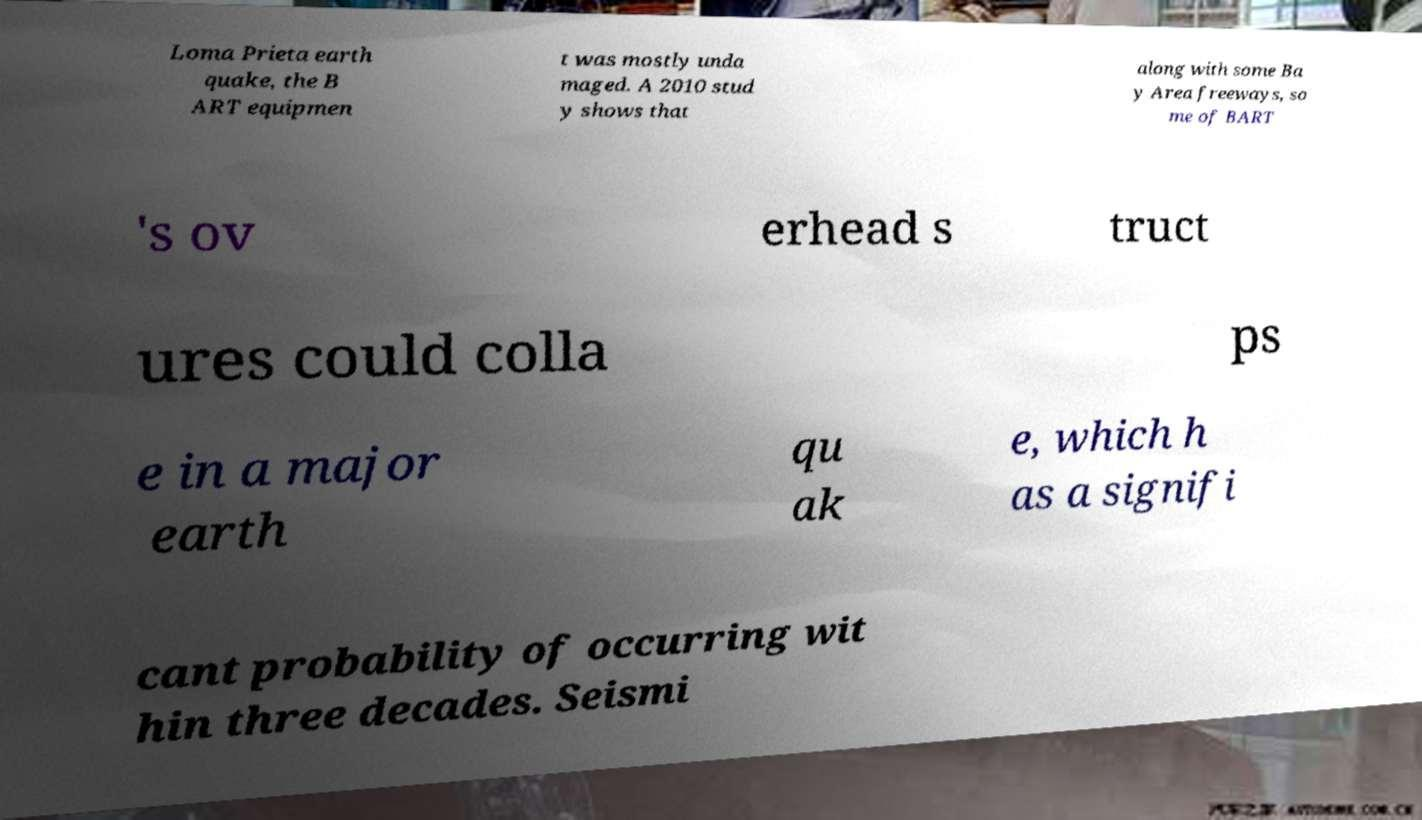Can you accurately transcribe the text from the provided image for me? Loma Prieta earth quake, the B ART equipmen t was mostly unda maged. A 2010 stud y shows that along with some Ba y Area freeways, so me of BART 's ov erhead s truct ures could colla ps e in a major earth qu ak e, which h as a signifi cant probability of occurring wit hin three decades. Seismi 